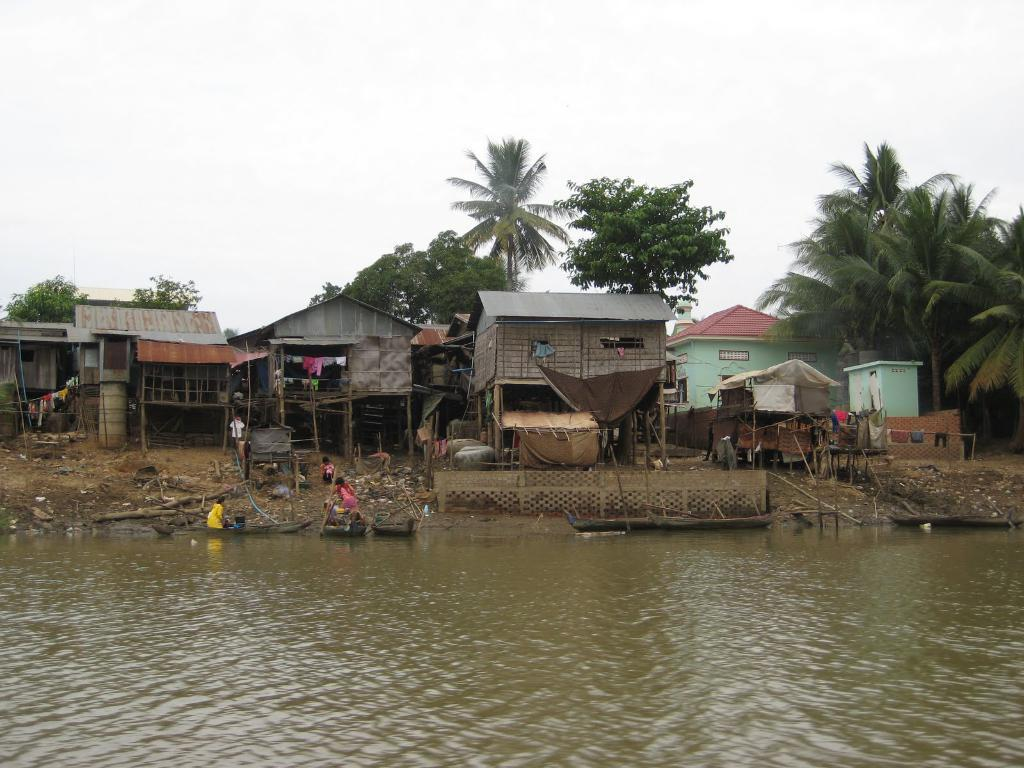What is at the bottom of the image? There is water at the bottom of the image. Who or what can be seen in the image? There are people in the image. What can be seen in the distance in the image? There are houses and trees in the background of the image. What is visible in the sky in the image? The sky is visible in the background of the image. What type of car is being driven by the visitor in the image? There is no car or visitor present in the image. What are the people in the image talking about? The conversation does not mention any specific topic that the people in the image might be discussing. 